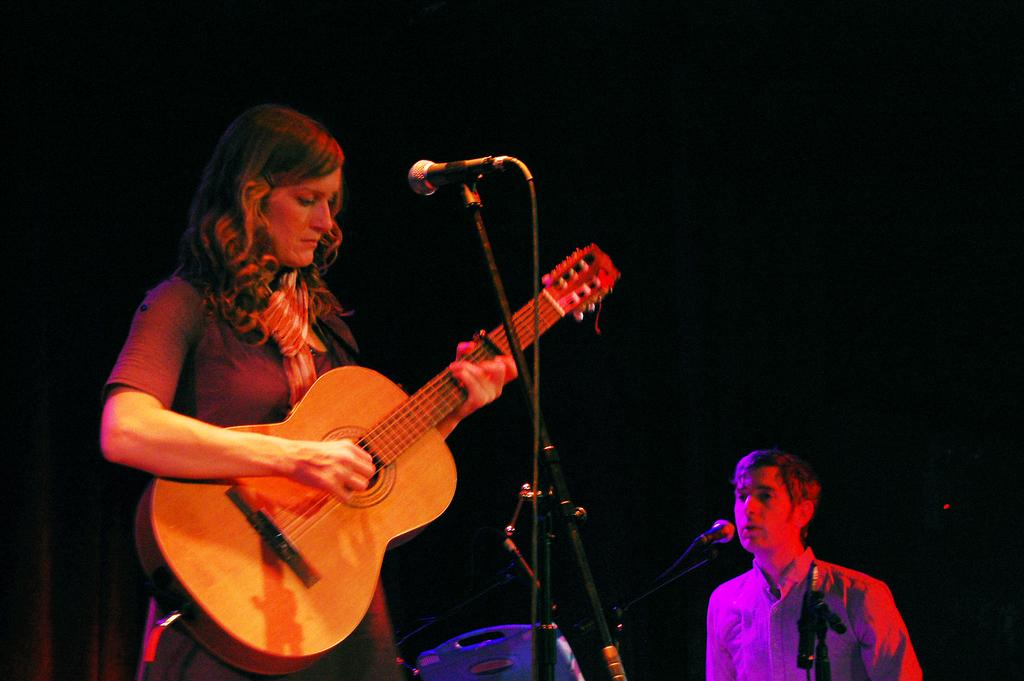What is the woman in the image doing? The woman is holding and playing a guitar. What can be seen near the woman? There is a microphone with a microphone stand. What is the man in the image doing? The man is standing and singing using a microphone. What type of board is the farmer using to cut the straw in the image? There is no farmer, board, or straw present in the image. 